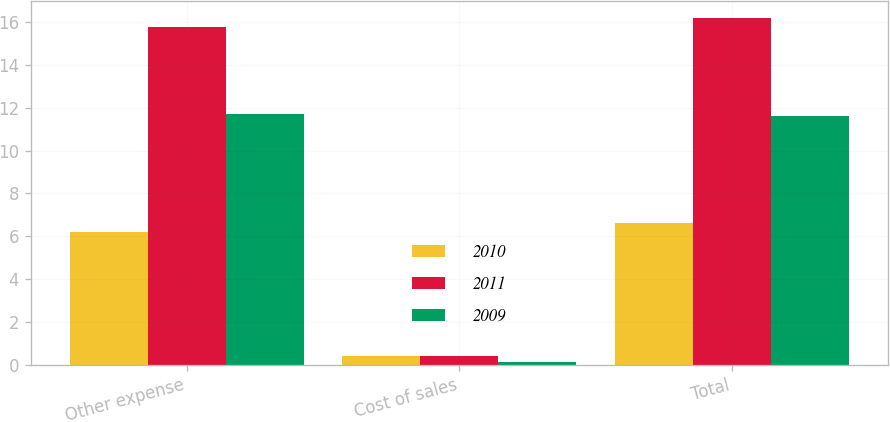Convert chart. <chart><loc_0><loc_0><loc_500><loc_500><stacked_bar_chart><ecel><fcel>Other expense<fcel>Cost of sales<fcel>Total<nl><fcel>2010<fcel>6.2<fcel>0.4<fcel>6.6<nl><fcel>2011<fcel>15.8<fcel>0.4<fcel>16.2<nl><fcel>2009<fcel>11.7<fcel>0.1<fcel>11.6<nl></chart> 